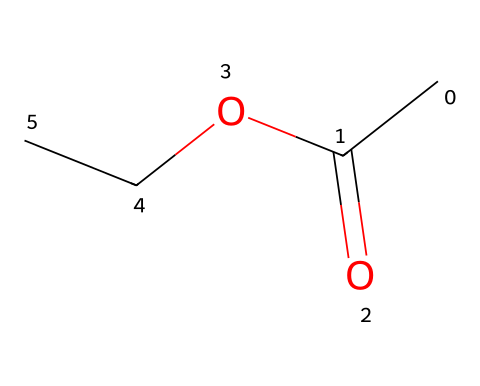What is the name of this chemical? The provided SMILES represents ethyl acetate, which is commonly known as a food flavoring additive.
Answer: ethyl acetate How many carbon atoms are in ethyl acetate? By analyzing the SMILES, there are two carbon atoms in the ethyl group (CC) and one carbon atom in the carbonyl group (=O), totaling three carbon atoms.
Answer: three What is the type of functional group present in ethyl acetate? In the structure, the presence of ester functional group is indicated by the -O- (with the carbonyl =O) connected to the carbon chain.
Answer: ester How many oxygen atoms are in ethyl acetate? The structure contains two oxygen atoms: one in the carbonyl (C=O) and one in the ether part (OCC).
Answer: two What type of bond connects the carbonyl carbon to the oxygen in ethyl acetate? The bond between the carbonyl carbon and the oxygen in the ester functional group is a single bond as represented by the structure (-O-).
Answer: single bond Is ethyl acetate a saturated or unsaturated compound? Based on its structure, ethyl acetate has no carbon-carbon double bonds, indicating it is saturated.
Answer: saturated How does the presence of the ester group affect the properties of ethyl acetate? The ester group contributes to the volatility and ability to act as a solvent and flavoring agent, impacting its solubility in organic solvents.
Answer: volatility 